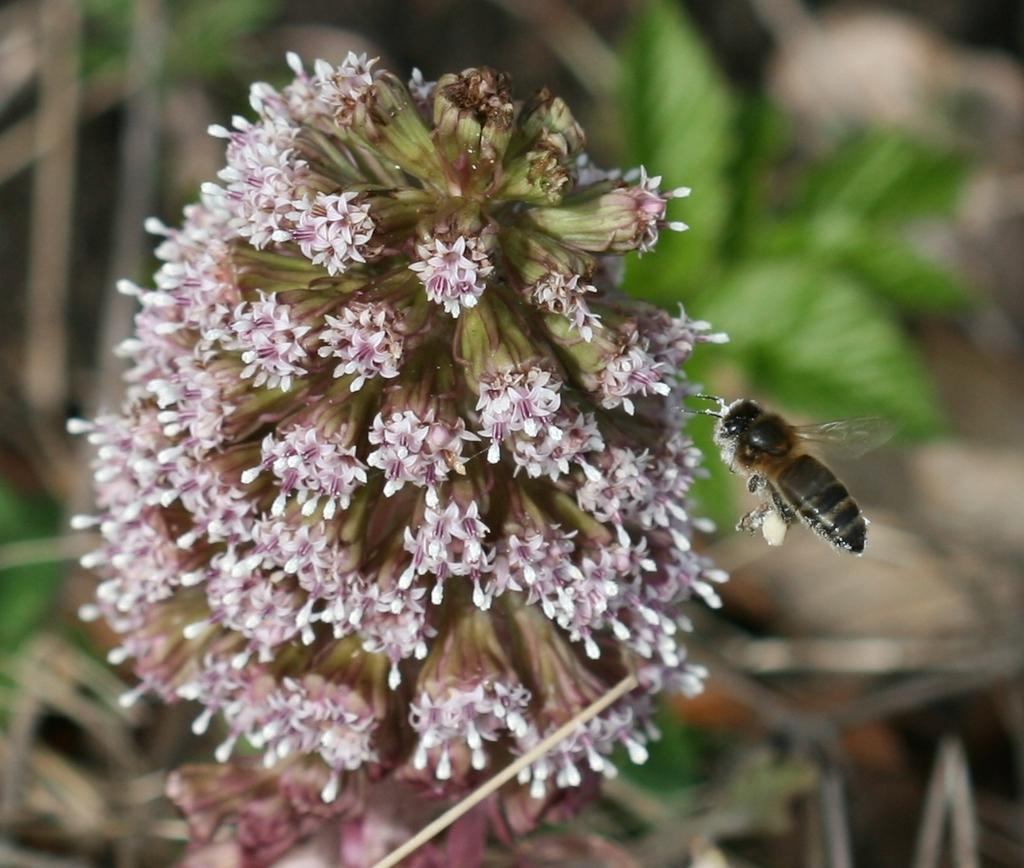What type of insect is present in the image? There is a honey bee in the image. What is the honey bee interacting with in the image? The honey bee is interacting with flowers in the image. Where are the honey bee and flowers located in the image? The honey bee and flowers are in the center of the image. Can you tell me how many snakes are slithering around the honey bee in the image? There are no snakes present in the image; it features a honey bee interacting with flowers. What type of map is visible in the image? There is no map present in the image. 